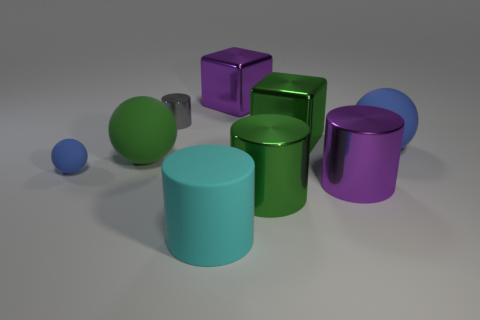How many cubes are either big cyan objects or tiny gray metal objects?
Keep it short and to the point. 0. There is a block that is behind the small shiny thing; what color is it?
Your answer should be very brief. Purple. What number of metal objects are either large green cubes or big cylinders?
Offer a very short reply. 3. There is a purple thing in front of the metallic thing on the left side of the cyan object; what is it made of?
Offer a terse response. Metal. There is a big object that is the same color as the tiny matte object; what material is it?
Give a very brief answer. Rubber. What is the color of the small rubber object?
Ensure brevity in your answer.  Blue. There is a large green shiny object behind the tiny blue sphere; is there a blue sphere behind it?
Ensure brevity in your answer.  No. What is the gray cylinder made of?
Provide a succinct answer. Metal. Do the purple object in front of the small gray shiny object and the tiny ball left of the small cylinder have the same material?
Your answer should be compact. No. Is there any other thing that is the same color as the small cylinder?
Offer a terse response. No. 